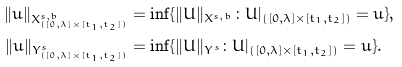Convert formula to latex. <formula><loc_0><loc_0><loc_500><loc_500>\| u \| _ { X ^ { s , b } _ { ( [ 0 , \lambda ] \times [ t _ { 1 } , t _ { 2 } ] ) } } & = \inf \{ \| U \| _ { X ^ { s , b } } \colon U | _ { ( [ 0 , \lambda ] \times [ t _ { 1 } , t _ { 2 } ] ) } = u \} , \\ \| u \| _ { Y ^ { s } _ { ( [ 0 , \lambda ] \times [ t _ { 1 } , t _ { 2 } ] ) } } & = \inf \{ \| U \| _ { Y ^ { s } } \colon U | _ { ( [ 0 , \lambda ] \times [ t _ { 1 } , t _ { 2 } ] ) } = u \} .</formula> 